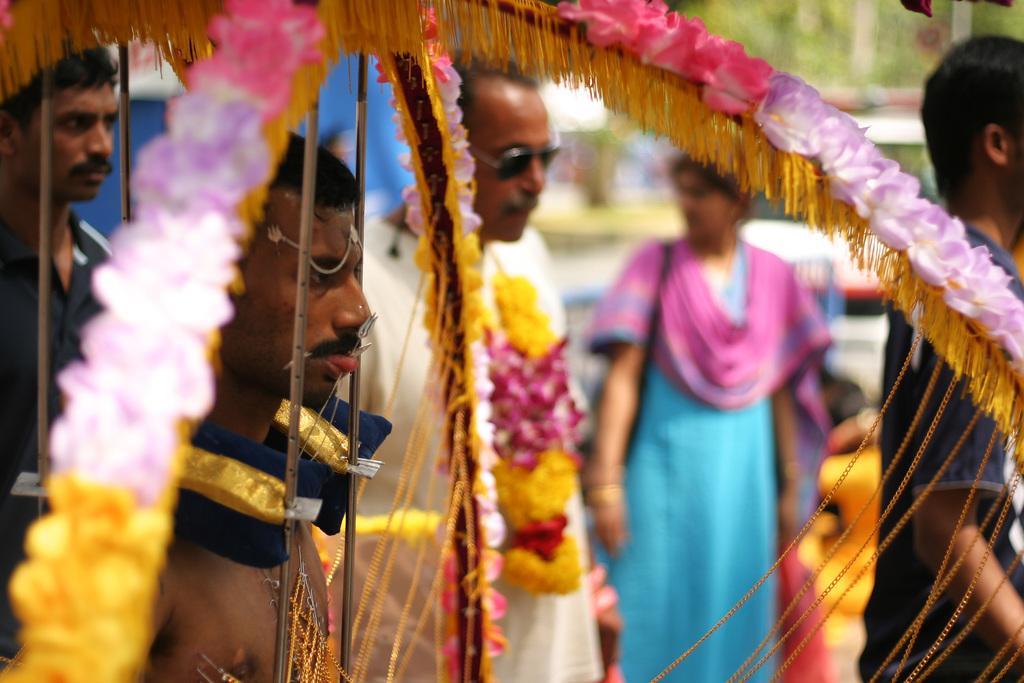Can you describe this image briefly? In this image I see few people and I see the decoration over here and I see a thing on this tongue of this man and it is blurred in the background. 